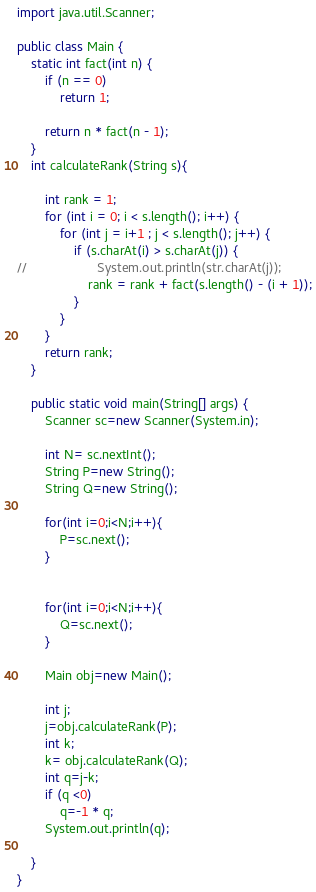<code> <loc_0><loc_0><loc_500><loc_500><_Java_>import java.util.Scanner;

public class Main {
    static int fact(int n) {
        if (n == 0)
            return 1;

        return n * fact(n - 1);
    }
    int calculateRank(String s){

        int rank = 1;
        for (int i = 0; i < s.length(); i++) {
            for (int j = i+1 ; j < s.length(); j++) {
                if (s.charAt(i) > s.charAt(j)) {
//                    System.out.println(str.charAt(j));
                    rank = rank + fact(s.length() - (i + 1));
                }
            }
        }
        return rank;
    }

    public static void main(String[] args) {
        Scanner sc=new Scanner(System.in);

        int N= sc.nextInt();
        String P=new String();
        String Q=new String();

        for(int i=0;i<N;i++){
            P=sc.next();
        }


        for(int i=0;i<N;i++){
            Q=sc.next();
        }

        Main obj=new Main();

        int j;
        j=obj.calculateRank(P);
        int k;
        k= obj.calculateRank(Q);
        int q=j-k;
        if (q <0)
            q=-1 * q;
        System.out.println(q);

    }
}
</code> 